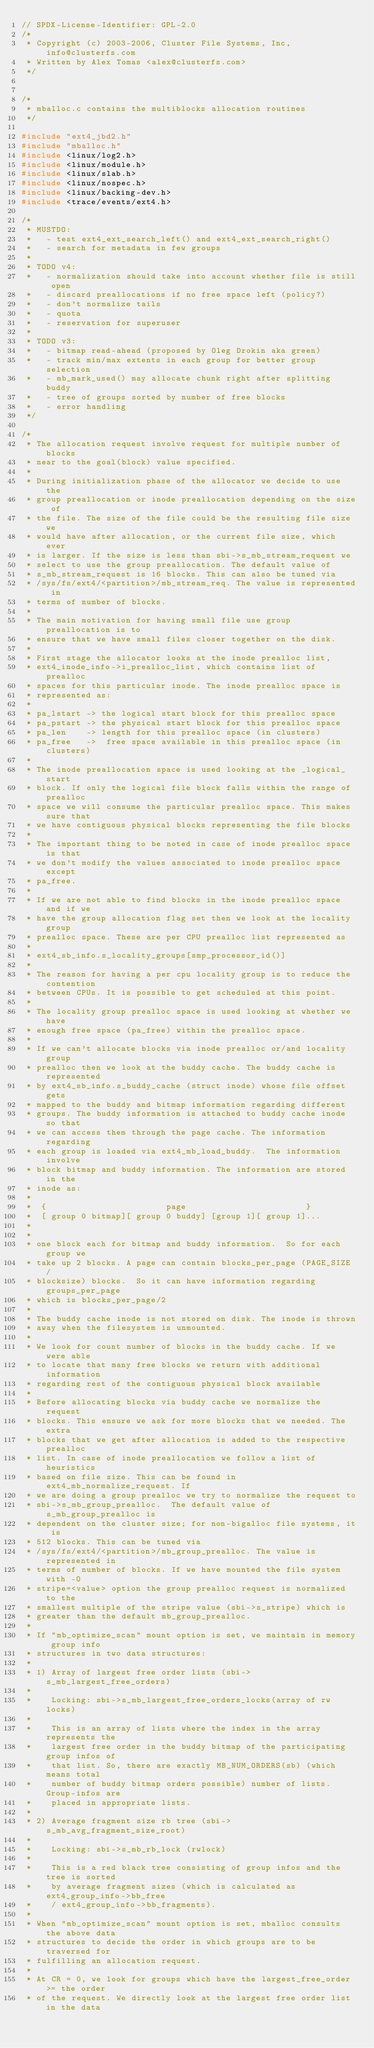<code> <loc_0><loc_0><loc_500><loc_500><_C_>// SPDX-License-Identifier: GPL-2.0
/*
 * Copyright (c) 2003-2006, Cluster File Systems, Inc, info@clusterfs.com
 * Written by Alex Tomas <alex@clusterfs.com>
 */


/*
 * mballoc.c contains the multiblocks allocation routines
 */

#include "ext4_jbd2.h"
#include "mballoc.h"
#include <linux/log2.h>
#include <linux/module.h>
#include <linux/slab.h>
#include <linux/nospec.h>
#include <linux/backing-dev.h>
#include <trace/events/ext4.h>

/*
 * MUSTDO:
 *   - test ext4_ext_search_left() and ext4_ext_search_right()
 *   - search for metadata in few groups
 *
 * TODO v4:
 *   - normalization should take into account whether file is still open
 *   - discard preallocations if no free space left (policy?)
 *   - don't normalize tails
 *   - quota
 *   - reservation for superuser
 *
 * TODO v3:
 *   - bitmap read-ahead (proposed by Oleg Drokin aka green)
 *   - track min/max extents in each group for better group selection
 *   - mb_mark_used() may allocate chunk right after splitting buddy
 *   - tree of groups sorted by number of free blocks
 *   - error handling
 */

/*
 * The allocation request involve request for multiple number of blocks
 * near to the goal(block) value specified.
 *
 * During initialization phase of the allocator we decide to use the
 * group preallocation or inode preallocation depending on the size of
 * the file. The size of the file could be the resulting file size we
 * would have after allocation, or the current file size, which ever
 * is larger. If the size is less than sbi->s_mb_stream_request we
 * select to use the group preallocation. The default value of
 * s_mb_stream_request is 16 blocks. This can also be tuned via
 * /sys/fs/ext4/<partition>/mb_stream_req. The value is represented in
 * terms of number of blocks.
 *
 * The main motivation for having small file use group preallocation is to
 * ensure that we have small files closer together on the disk.
 *
 * First stage the allocator looks at the inode prealloc list,
 * ext4_inode_info->i_prealloc_list, which contains list of prealloc
 * spaces for this particular inode. The inode prealloc space is
 * represented as:
 *
 * pa_lstart -> the logical start block for this prealloc space
 * pa_pstart -> the physical start block for this prealloc space
 * pa_len    -> length for this prealloc space (in clusters)
 * pa_free   ->  free space available in this prealloc space (in clusters)
 *
 * The inode preallocation space is used looking at the _logical_ start
 * block. If only the logical file block falls within the range of prealloc
 * space we will consume the particular prealloc space. This makes sure that
 * we have contiguous physical blocks representing the file blocks
 *
 * The important thing to be noted in case of inode prealloc space is that
 * we don't modify the values associated to inode prealloc space except
 * pa_free.
 *
 * If we are not able to find blocks in the inode prealloc space and if we
 * have the group allocation flag set then we look at the locality group
 * prealloc space. These are per CPU prealloc list represented as
 *
 * ext4_sb_info.s_locality_groups[smp_processor_id()]
 *
 * The reason for having a per cpu locality group is to reduce the contention
 * between CPUs. It is possible to get scheduled at this point.
 *
 * The locality group prealloc space is used looking at whether we have
 * enough free space (pa_free) within the prealloc space.
 *
 * If we can't allocate blocks via inode prealloc or/and locality group
 * prealloc then we look at the buddy cache. The buddy cache is represented
 * by ext4_sb_info.s_buddy_cache (struct inode) whose file offset gets
 * mapped to the buddy and bitmap information regarding different
 * groups. The buddy information is attached to buddy cache inode so that
 * we can access them through the page cache. The information regarding
 * each group is loaded via ext4_mb_load_buddy.  The information involve
 * block bitmap and buddy information. The information are stored in the
 * inode as:
 *
 *  {                        page                        }
 *  [ group 0 bitmap][ group 0 buddy] [group 1][ group 1]...
 *
 *
 * one block each for bitmap and buddy information.  So for each group we
 * take up 2 blocks. A page can contain blocks_per_page (PAGE_SIZE /
 * blocksize) blocks.  So it can have information regarding groups_per_page
 * which is blocks_per_page/2
 *
 * The buddy cache inode is not stored on disk. The inode is thrown
 * away when the filesystem is unmounted.
 *
 * We look for count number of blocks in the buddy cache. If we were able
 * to locate that many free blocks we return with additional information
 * regarding rest of the contiguous physical block available
 *
 * Before allocating blocks via buddy cache we normalize the request
 * blocks. This ensure we ask for more blocks that we needed. The extra
 * blocks that we get after allocation is added to the respective prealloc
 * list. In case of inode preallocation we follow a list of heuristics
 * based on file size. This can be found in ext4_mb_normalize_request. If
 * we are doing a group prealloc we try to normalize the request to
 * sbi->s_mb_group_prealloc.  The default value of s_mb_group_prealloc is
 * dependent on the cluster size; for non-bigalloc file systems, it is
 * 512 blocks. This can be tuned via
 * /sys/fs/ext4/<partition>/mb_group_prealloc. The value is represented in
 * terms of number of blocks. If we have mounted the file system with -O
 * stripe=<value> option the group prealloc request is normalized to the
 * smallest multiple of the stripe value (sbi->s_stripe) which is
 * greater than the default mb_group_prealloc.
 *
 * If "mb_optimize_scan" mount option is set, we maintain in memory group info
 * structures in two data structures:
 *
 * 1) Array of largest free order lists (sbi->s_mb_largest_free_orders)
 *
 *    Locking: sbi->s_mb_largest_free_orders_locks(array of rw locks)
 *
 *    This is an array of lists where the index in the array represents the
 *    largest free order in the buddy bitmap of the participating group infos of
 *    that list. So, there are exactly MB_NUM_ORDERS(sb) (which means total
 *    number of buddy bitmap orders possible) number of lists. Group-infos are
 *    placed in appropriate lists.
 *
 * 2) Average fragment size rb tree (sbi->s_mb_avg_fragment_size_root)
 *
 *    Locking: sbi->s_mb_rb_lock (rwlock)
 *
 *    This is a red black tree consisting of group infos and the tree is sorted
 *    by average fragment sizes (which is calculated as ext4_group_info->bb_free
 *    / ext4_group_info->bb_fragments).
 *
 * When "mb_optimize_scan" mount option is set, mballoc consults the above data
 * structures to decide the order in which groups are to be traversed for
 * fulfilling an allocation request.
 *
 * At CR = 0, we look for groups which have the largest_free_order >= the order
 * of the request. We directly look at the largest free order list in the data</code> 